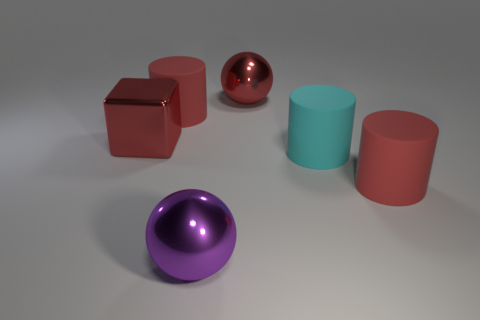There is a shiny object that is the same color as the large cube; what is its shape?
Your answer should be very brief. Sphere. Are there any matte cylinders of the same color as the large cube?
Give a very brief answer. Yes. What is the material of the big sphere that is the same color as the large block?
Keep it short and to the point. Metal. Is there another big rubber thing that has the same shape as the cyan thing?
Offer a very short reply. Yes. What is the material of the cyan cylinder that is the same size as the metal block?
Keep it short and to the point. Rubber. Is the number of rubber cylinders greater than the number of large metal cylinders?
Your answer should be very brief. Yes. There is a purple metal thing that is the same size as the cyan cylinder; what is its shape?
Make the answer very short. Sphere. The red shiny thing in front of the large ball behind the red rubber cylinder that is behind the red block is what shape?
Make the answer very short. Cube. There is a large matte cylinder that is on the left side of the big purple thing; is its color the same as the big sphere that is to the right of the large purple metallic object?
Your response must be concise. Yes. How many tiny cyan matte cylinders are there?
Offer a terse response. 0. 